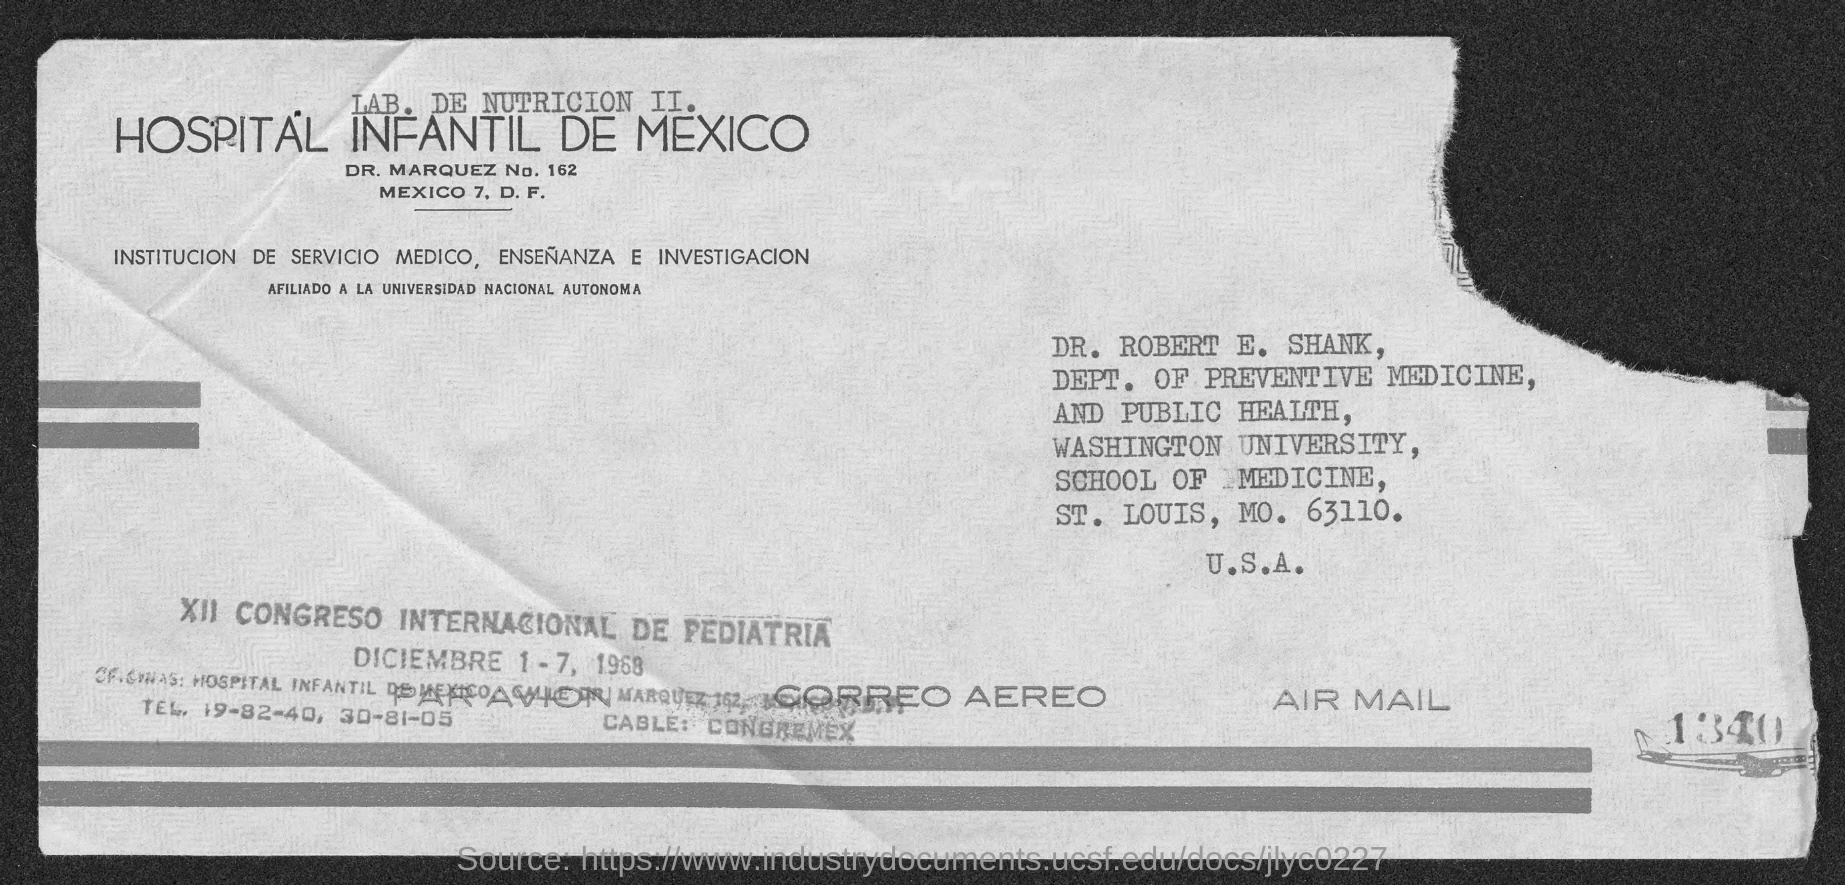Outline some significant characteristics in this image. The letter is addressed to Dr. Robert E. Shank. 